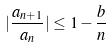Convert formula to latex. <formula><loc_0><loc_0><loc_500><loc_500>| \frac { a _ { n + 1 } } { a _ { n } } | \leq 1 - \frac { b } { n }</formula> 